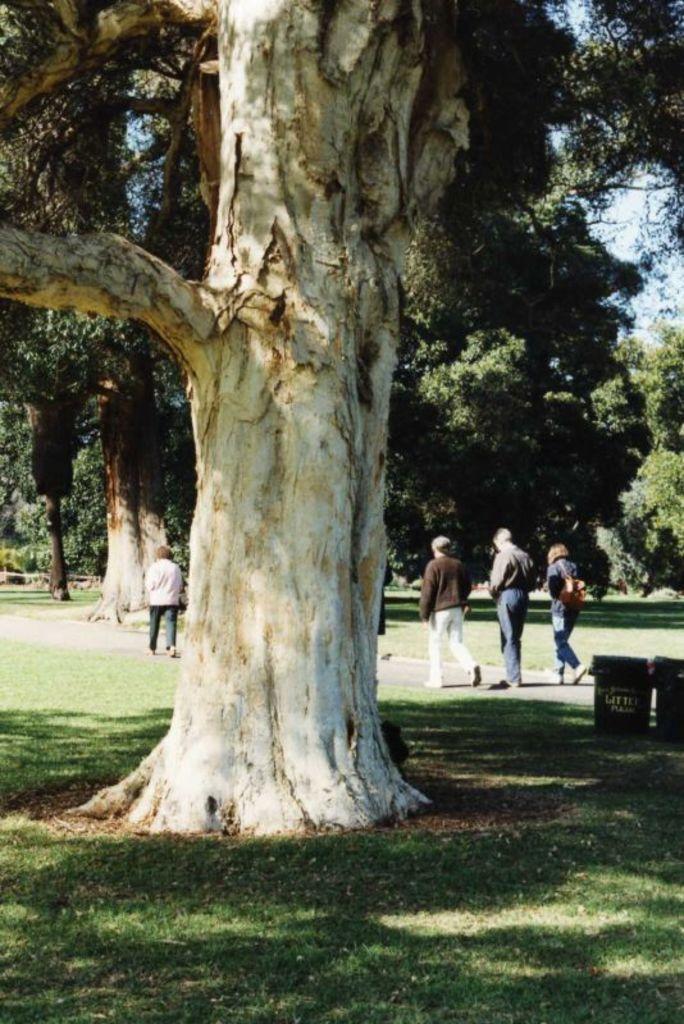How would you summarize this image in a sentence or two? There is one tree at the bottom of this image. There are some persons walking as we can see in the middle of this image. There are some other trees in the background. 